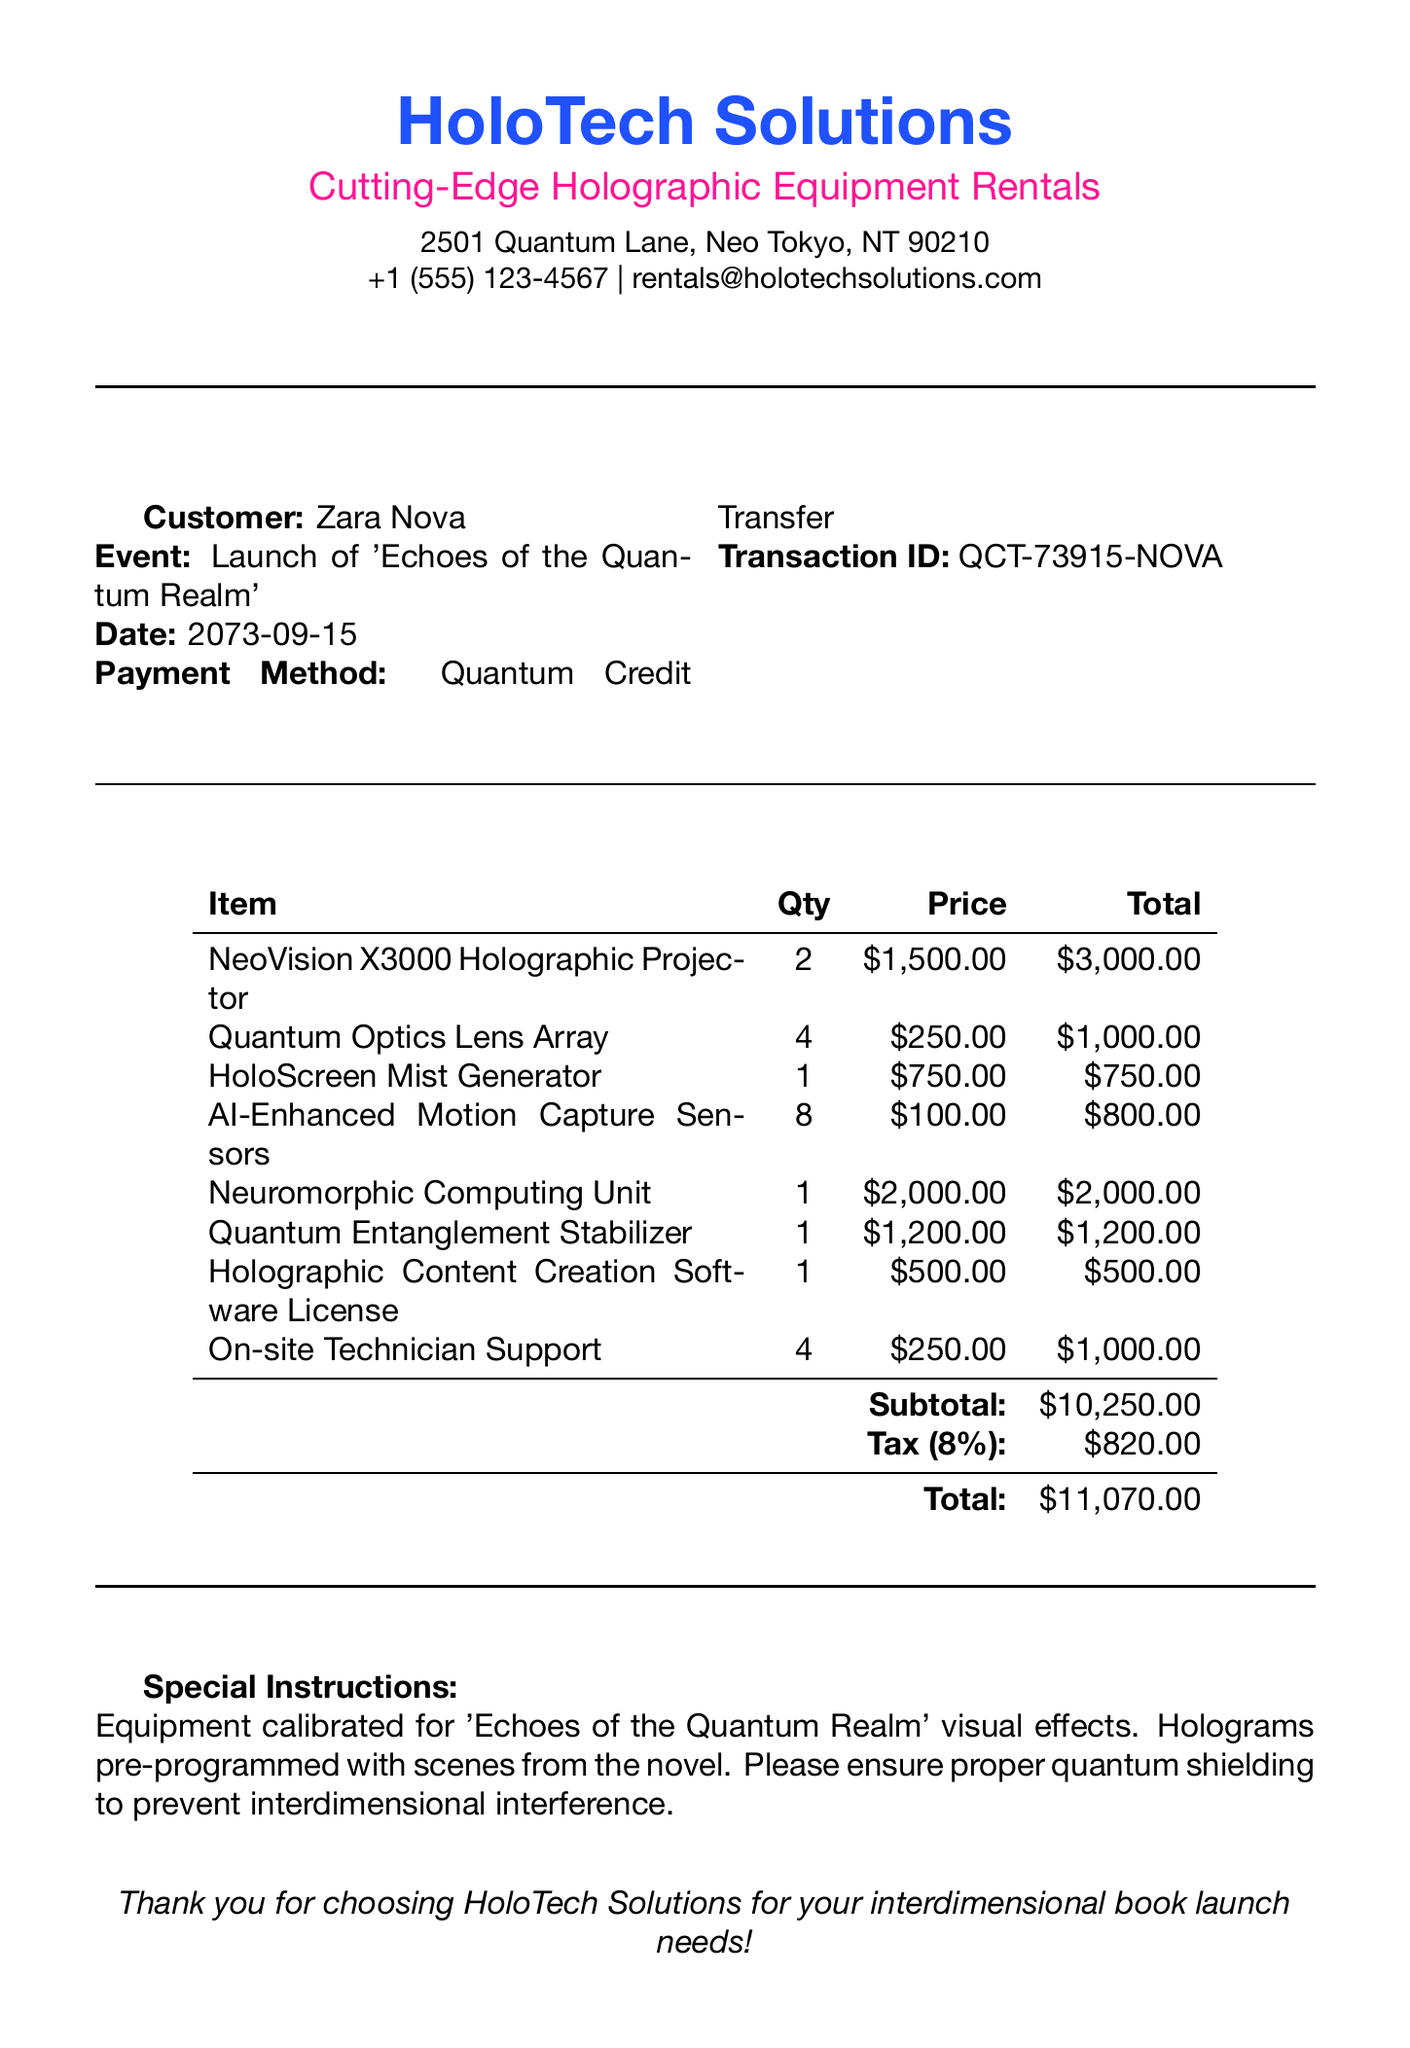What is the customer's name? The customer's name is listed at the top of the receipt.
Answer: Zara Nova What is the date of the event? The event date is specified in the document under the event details.
Answer: 2073-09-15 How many NeoVision X3000 Holographic Projectors were rented? This information is found in the itemized list of the receipt.
Answer: 2 What is the total amount paid? The total amount is calculated and stated at the end of the receipt.
Answer: $11,070.00 What is the price of the Quantum Optics Lens Array? The price for this item is detailed in the itemized section.
Answer: $250.00 What special instructions are given regarding the equipment? The special instructions are provided in a dedicated section toward the end of the receipt.
Answer: Equipment calibrated for 'Echoes of the Quantum Realm' visual effects What payment method was used for the transaction? The method of payment is mentioned in the customer payment details.
Answer: Quantum Credit Transfer How much was charged for tax? The tax amount is specified in the totals section of the receipt.
Answer: $820.00 What is the transaction ID? The transaction ID is labeled in the payment details.
Answer: QCT-73915-NOVA 